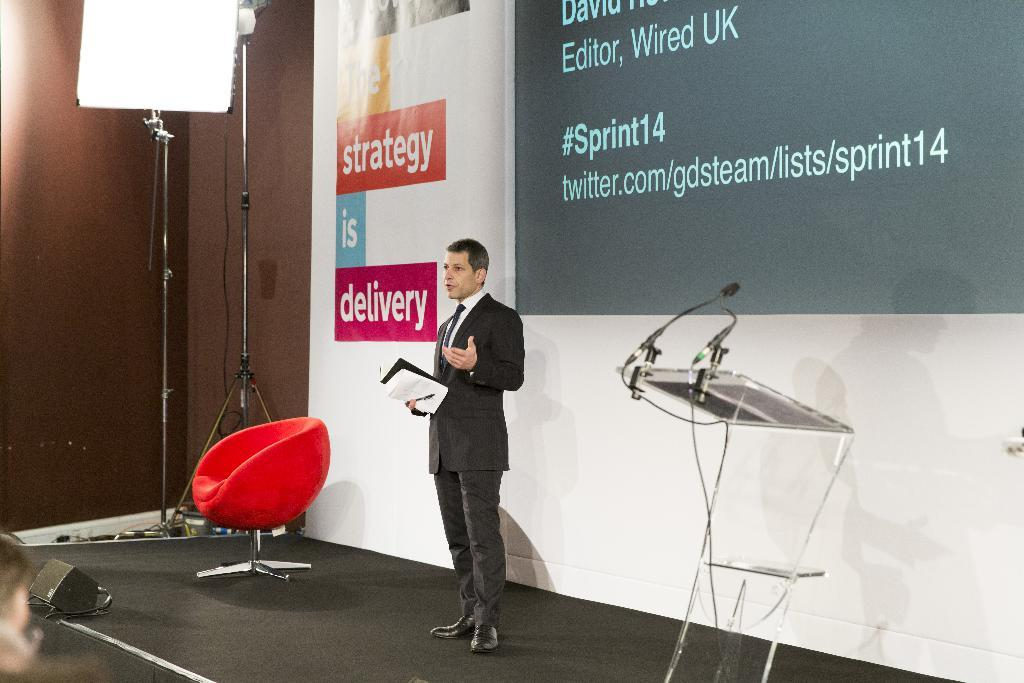What is the man in the image doing? The man is standing on the stage and speaking. What is the man using to support his speech? There is a podium on the stage that the man might be using. What other furniture is present on the stage? There is a chair on the stage. What equipment is used for amplifying sound in the image? There are speakers on the stage. What can be seen in the background of the image? There is a banner in the image. What type of twig is the man holding in his hand while speaking? There is no twig present in the image; the man is speaking without any visible props. 